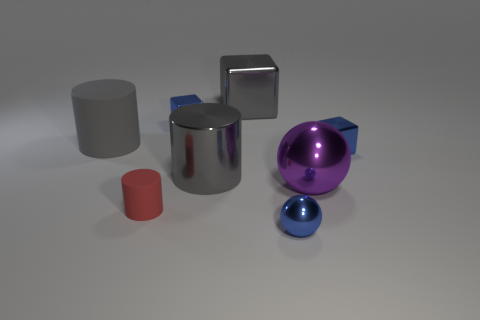Subtract all purple cubes. How many gray cylinders are left? 2 Subtract all rubber cylinders. How many cylinders are left? 1 Subtract 1 cylinders. How many cylinders are left? 2 Add 2 blue objects. How many objects exist? 10 Subtract all cyan cylinders. Subtract all yellow blocks. How many cylinders are left? 3 Subtract all cubes. How many objects are left? 5 Add 3 big gray rubber objects. How many big gray rubber objects are left? 4 Add 8 large blue rubber objects. How many large blue rubber objects exist? 8 Subtract 0 green spheres. How many objects are left? 8 Subtract all small red shiny cubes. Subtract all big cylinders. How many objects are left? 6 